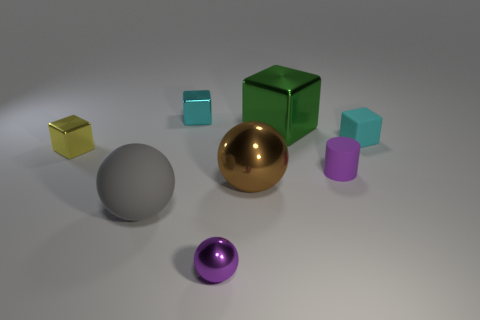Is there any other thing that has the same shape as the tiny purple matte thing?
Give a very brief answer. No. What is the material of the sphere that is behind the big gray object?
Offer a terse response. Metal. What size is the gray object that is the same shape as the purple metal object?
Offer a very short reply. Large. What number of gray things have the same material as the large cube?
Ensure brevity in your answer.  0. How many metal things are the same color as the small rubber cylinder?
Make the answer very short. 1. How many objects are big green metal objects right of the tiny yellow metal cube or tiny things that are behind the rubber sphere?
Your response must be concise. 5. Are there fewer big green metal objects that are right of the large green shiny thing than cyan cylinders?
Offer a very short reply. No. Is there a yellow metallic thing of the same size as the brown thing?
Offer a very short reply. No. What color is the cylinder?
Keep it short and to the point. Purple. Is the brown metal thing the same size as the purple metallic thing?
Offer a very short reply. No. 